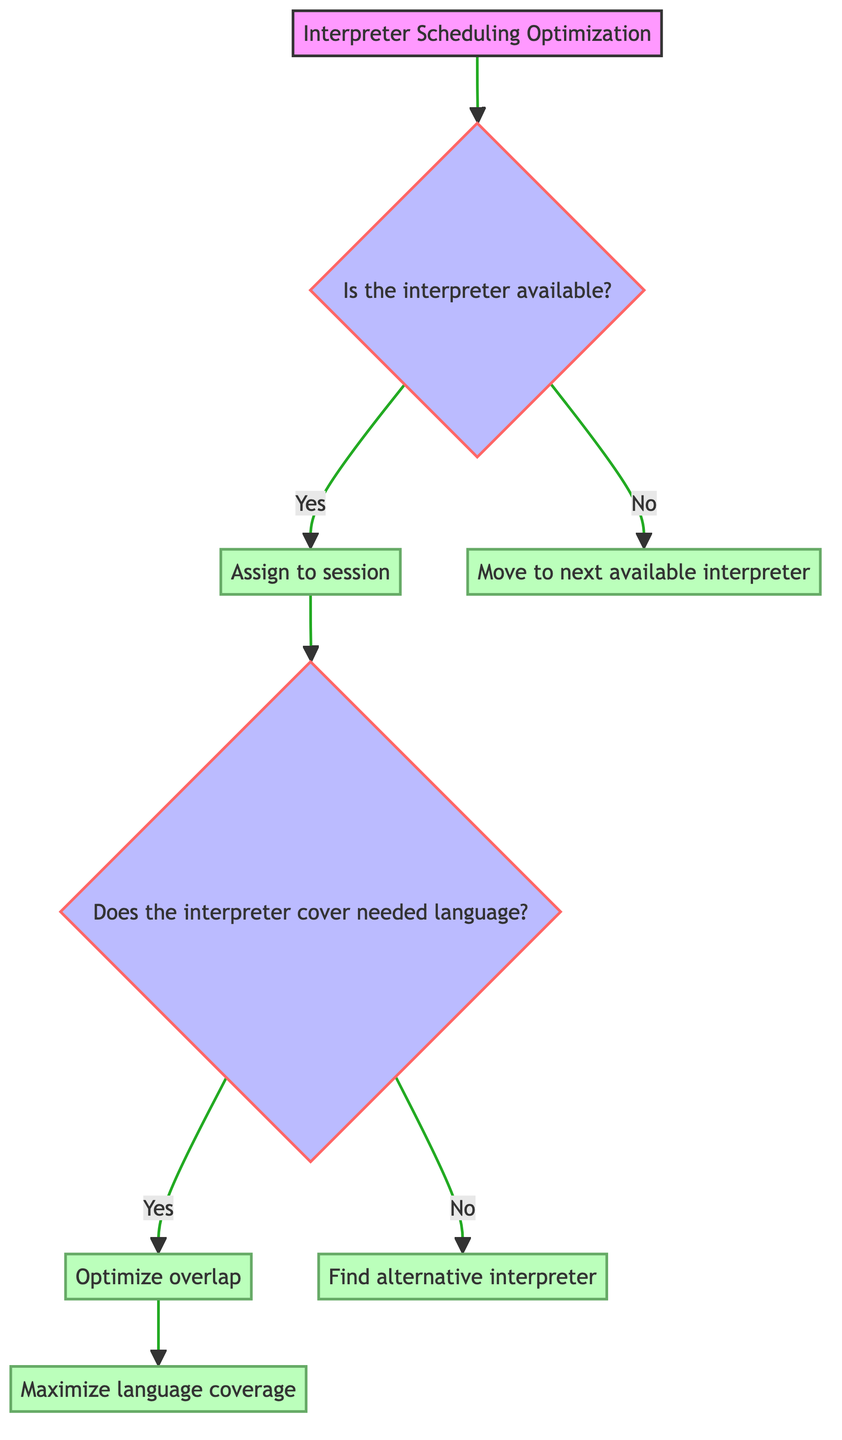What is the starting point of the diagram? The starting point of the diagram is the root node labeled "Interpreter Scheduling Optimization." This is the first node from which the decision-making process flows.
Answer: Interpreter Scheduling Optimization How many decision nodes are in the diagram? There are two decision nodes in the diagram. The first is about interpreter availability, and the second addresses whether the interpreter covers the needed language, making a total of two decision nodes.
Answer: Two What happens if the interpreter is not available? If the interpreter is not available, the flow directs to the leaf node labeled "Move to next available interpreter." This is the action taken when there's no availability.
Answer: Move to next available interpreter What language-related decision follows after assigning an interpreter to a session? After assigning an interpreter to a session, the next decision is whether the interpreter covers the needed language. This decision determines the next course of action based on language competency.
Answer: Does the interpreter cover needed language? What action is taken if the interpreter does cover the needed language? If the interpreter does cover the needed language, the flow leads to the leaf node labeled "Optimize overlap." This is the resultant action aimed at improving scheduling efficiency with the correct interpreter.
Answer: Optimize overlap What are the outcomes if the interpreter does not cover the needed language? If the interpreter does not cover the needed language, it leads to the leaf node labeled "Find alternative interpreter." This represents the action taken when the interpreter's language skills do not meet the session's requirements.
Answer: Find alternative interpreter What is the final outcome if an interpreter has been assigned and covers the language? The final outcome is to "Maximize language coverage." This indicates the end goal of the decision-making process aimed at ensuring that language needs are effectively met during the scheduling of interpreters.
Answer: Maximize language coverage 